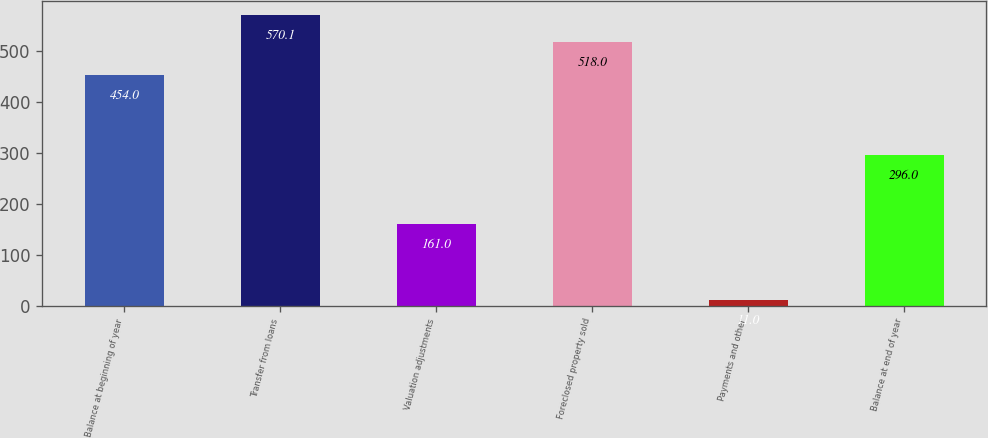Convert chart to OTSL. <chart><loc_0><loc_0><loc_500><loc_500><bar_chart><fcel>Balance at beginning of year<fcel>Transfer from loans<fcel>Valuation adjustments<fcel>Foreclosed property sold<fcel>Payments and other<fcel>Balance at end of year<nl><fcel>454<fcel>570.1<fcel>161<fcel>518<fcel>11<fcel>296<nl></chart> 